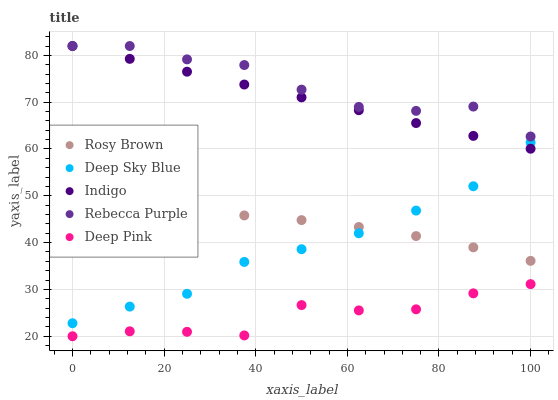Does Deep Pink have the minimum area under the curve?
Answer yes or no. Yes. Does Rebecca Purple have the maximum area under the curve?
Answer yes or no. Yes. Does Indigo have the minimum area under the curve?
Answer yes or no. No. Does Indigo have the maximum area under the curve?
Answer yes or no. No. Is Indigo the smoothest?
Answer yes or no. Yes. Is Deep Pink the roughest?
Answer yes or no. Yes. Is Rebecca Purple the smoothest?
Answer yes or no. No. Is Rebecca Purple the roughest?
Answer yes or no. No. Does Deep Pink have the lowest value?
Answer yes or no. Yes. Does Indigo have the lowest value?
Answer yes or no. No. Does Rebecca Purple have the highest value?
Answer yes or no. Yes. Does Deep Sky Blue have the highest value?
Answer yes or no. No. Is Deep Pink less than Indigo?
Answer yes or no. Yes. Is Rebecca Purple greater than Rosy Brown?
Answer yes or no. Yes. Does Rosy Brown intersect Deep Sky Blue?
Answer yes or no. Yes. Is Rosy Brown less than Deep Sky Blue?
Answer yes or no. No. Is Rosy Brown greater than Deep Sky Blue?
Answer yes or no. No. Does Deep Pink intersect Indigo?
Answer yes or no. No. 